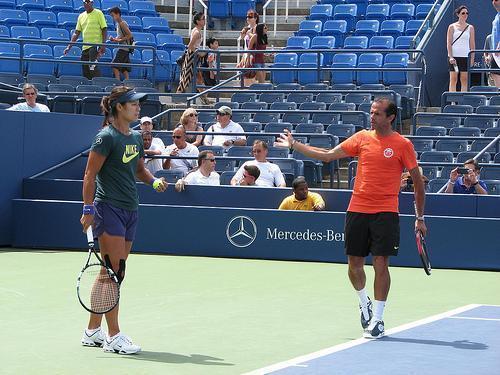How many people are with her?
Give a very brief answer. 1. 